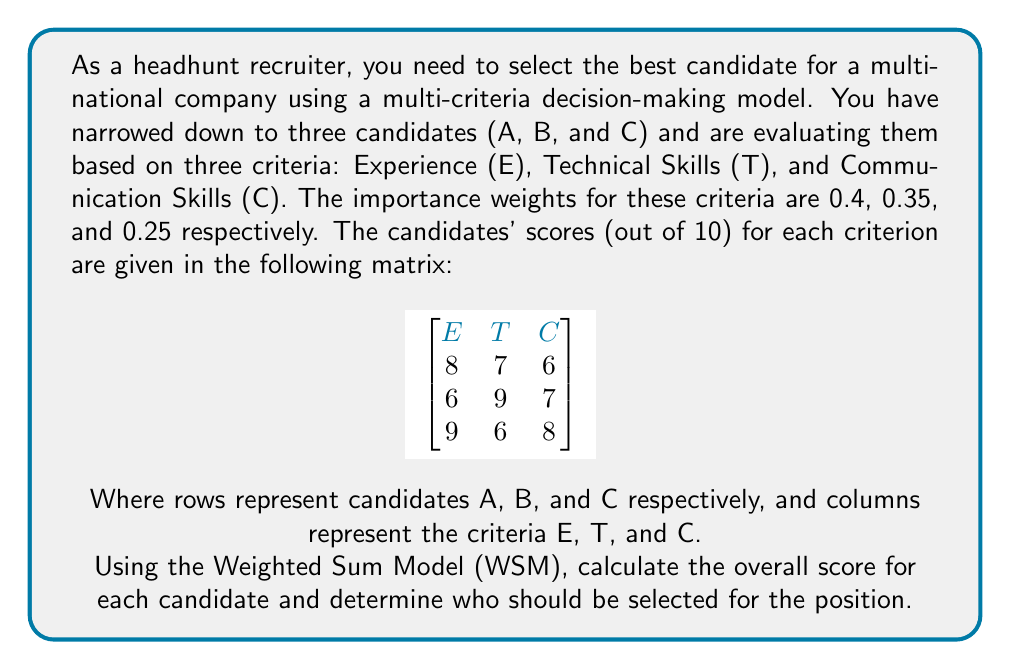Help me with this question. To solve this problem using the Weighted Sum Model (WSM), we'll follow these steps:

1. Identify the given information:
   - Criteria weights: $w_E = 0.4$, $w_T = 0.35$, $w_C = 0.25$
   - Candidate scores matrix:
     $$
     \begin{bmatrix}
     8 & 7 & 6 \\
     6 & 9 & 7 \\
     9 & 6 & 8
     \end{bmatrix}
     $$

2. Calculate the weighted score for each candidate using the formula:
   $WSM_i = \sum_{j=1}^n w_j \times a_{ij}$
   Where $i$ is the candidate, $j$ is the criterion, $w_j$ is the weight of criterion $j$, and $a_{ij}$ is the score of candidate $i$ for criterion $j$.

3. Calculate for Candidate A:
   $WSM_A = (0.4 \times 8) + (0.35 \times 7) + (0.25 \times 6)$
   $WSM_A = 3.2 + 2.45 + 1.5 = 7.15$

4. Calculate for Candidate B:
   $WSM_B = (0.4 \times 6) + (0.35 \times 9) + (0.25 \times 7)$
   $WSM_B = 2.4 + 3.15 + 1.75 = 7.30$

5. Calculate for Candidate C:
   $WSM_C = (0.4 \times 9) + (0.35 \times 6) + (0.25 \times 8)$
   $WSM_C = 3.6 + 2.1 + 2 = 7.70$

6. Compare the overall scores:
   Candidate A: 7.15
   Candidate B: 7.30
   Candidate C: 7.70

7. The candidate with the highest overall score should be selected.
Answer: Candidate C (7.70) 